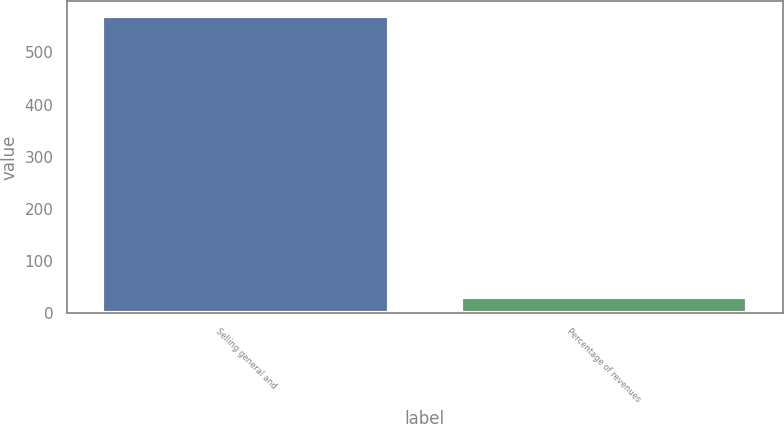Convert chart. <chart><loc_0><loc_0><loc_500><loc_500><bar_chart><fcel>Selling general and<fcel>Percentage of revenues<nl><fcel>569<fcel>31.4<nl></chart> 